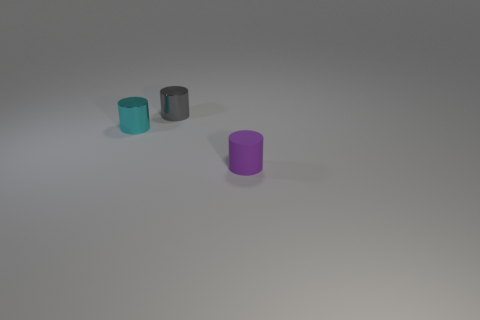Add 3 tiny gray metallic cylinders. How many objects exist? 6 Subtract 0 blue balls. How many objects are left? 3 Subtract all small purple rubber spheres. Subtract all tiny matte objects. How many objects are left? 2 Add 3 small purple rubber cylinders. How many small purple rubber cylinders are left? 4 Add 3 tiny gray metal objects. How many tiny gray metal objects exist? 4 